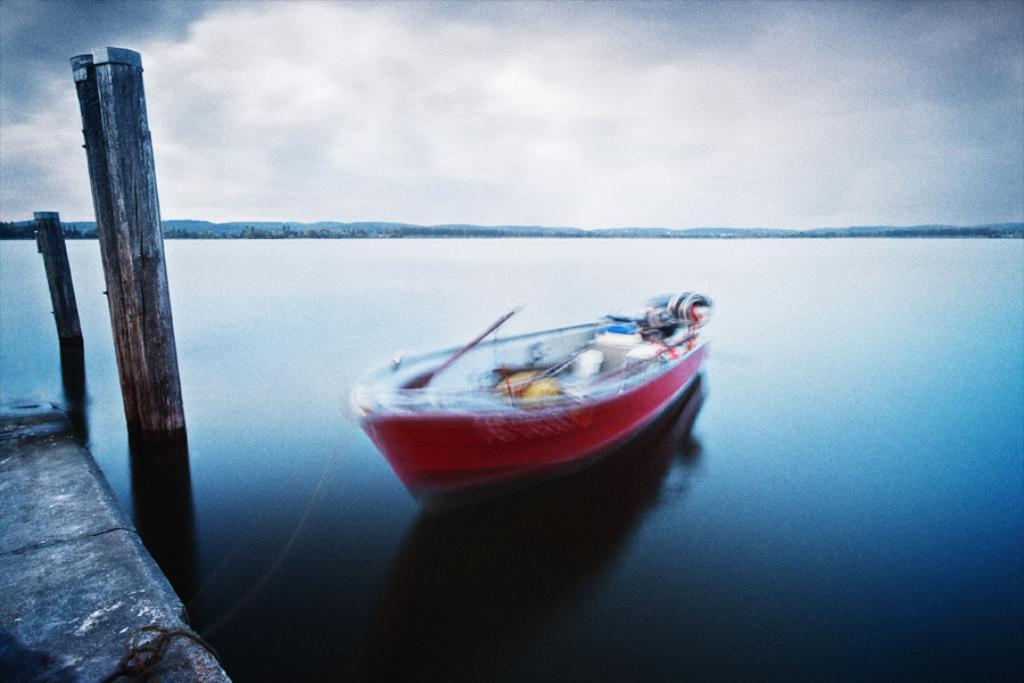What is the main subject of the image? The main subject of the image is a boat. Where is the boat located in the image? The boat is in the water. What is the color of the boat? The boat is red in color. How would you describe the sky in the image? The sky is cloudy in the image. What can be seen on the left side of the image? There are wooden logs on the left side of the image. How many chickens are on the boat in the image? There are no chickens present in the image. Is there a skateboard visible on the boat in the image? There is no skateboard visible in the image. 